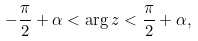<formula> <loc_0><loc_0><loc_500><loc_500>- \frac { \pi } { 2 } + \alpha < \arg z < \frac { \pi } { 2 } + \alpha ,</formula> 